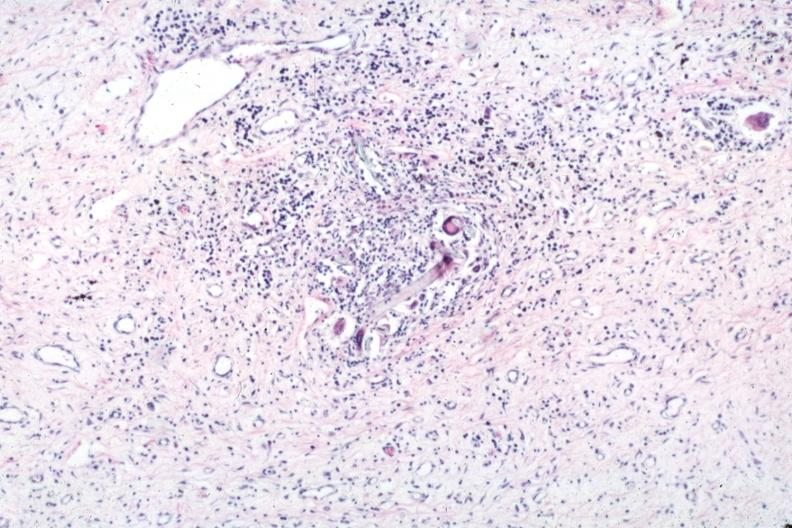what is present?
Answer the question using a single word or phrase. Suture granuloma 